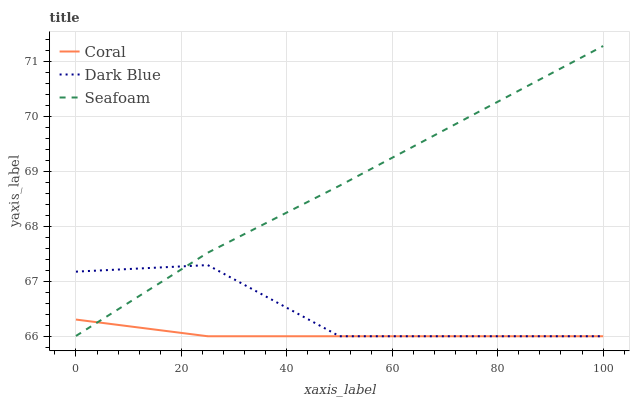Does Coral have the minimum area under the curve?
Answer yes or no. Yes. Does Seafoam have the maximum area under the curve?
Answer yes or no. Yes. Does Seafoam have the minimum area under the curve?
Answer yes or no. No. Does Coral have the maximum area under the curve?
Answer yes or no. No. Is Coral the smoothest?
Answer yes or no. Yes. Is Dark Blue the roughest?
Answer yes or no. Yes. Is Seafoam the smoothest?
Answer yes or no. No. Is Seafoam the roughest?
Answer yes or no. No. Does Dark Blue have the lowest value?
Answer yes or no. Yes. Does Seafoam have the lowest value?
Answer yes or no. No. Does Seafoam have the highest value?
Answer yes or no. Yes. Does Coral have the highest value?
Answer yes or no. No. Does Seafoam intersect Dark Blue?
Answer yes or no. Yes. Is Seafoam less than Dark Blue?
Answer yes or no. No. Is Seafoam greater than Dark Blue?
Answer yes or no. No. 